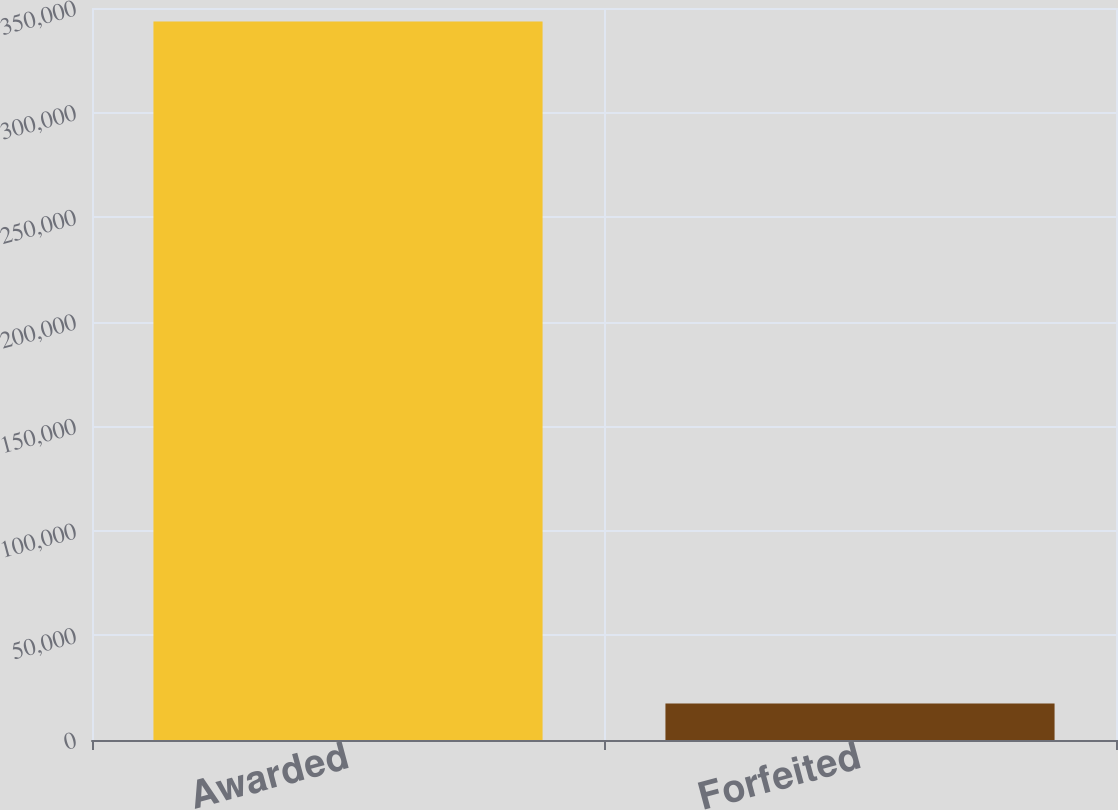<chart> <loc_0><loc_0><loc_500><loc_500><bar_chart><fcel>Awarded<fcel>Forfeited<nl><fcel>343500<fcel>17438<nl></chart> 